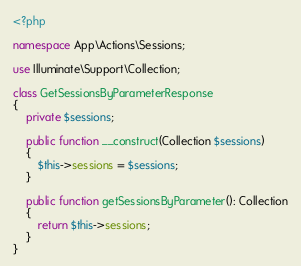Convert code to text. <code><loc_0><loc_0><loc_500><loc_500><_PHP_><?php

namespace App\Actions\Sessions;

use Illuminate\Support\Collection;

class GetSessionsByParameterResponse
{
    private $sessions;

    public function __construct(Collection $sessions)
    {
        $this->sessions = $sessions;
    }

    public function getSessionsByParameter(): Collection
    {
        return $this->sessions;
    }
}</code> 